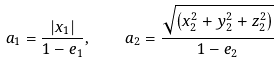<formula> <loc_0><loc_0><loc_500><loc_500>a _ { 1 } = \frac { \left | x _ { 1 } \right | } { 1 - e _ { 1 } } , \quad a _ { 2 } = \frac { \sqrt { \left ( x _ { 2 } ^ { 2 } + y _ { 2 } ^ { 2 } + z _ { 2 } ^ { 2 } \right ) } } { 1 - e _ { 2 } }</formula> 